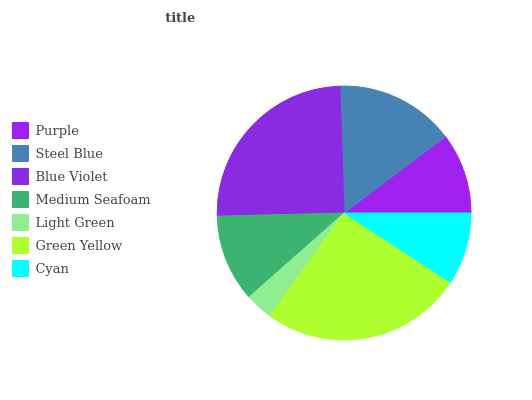Is Light Green the minimum?
Answer yes or no. Yes. Is Green Yellow the maximum?
Answer yes or no. Yes. Is Steel Blue the minimum?
Answer yes or no. No. Is Steel Blue the maximum?
Answer yes or no. No. Is Steel Blue greater than Purple?
Answer yes or no. Yes. Is Purple less than Steel Blue?
Answer yes or no. Yes. Is Purple greater than Steel Blue?
Answer yes or no. No. Is Steel Blue less than Purple?
Answer yes or no. No. Is Medium Seafoam the high median?
Answer yes or no. Yes. Is Medium Seafoam the low median?
Answer yes or no. Yes. Is Light Green the high median?
Answer yes or no. No. Is Green Yellow the low median?
Answer yes or no. No. 